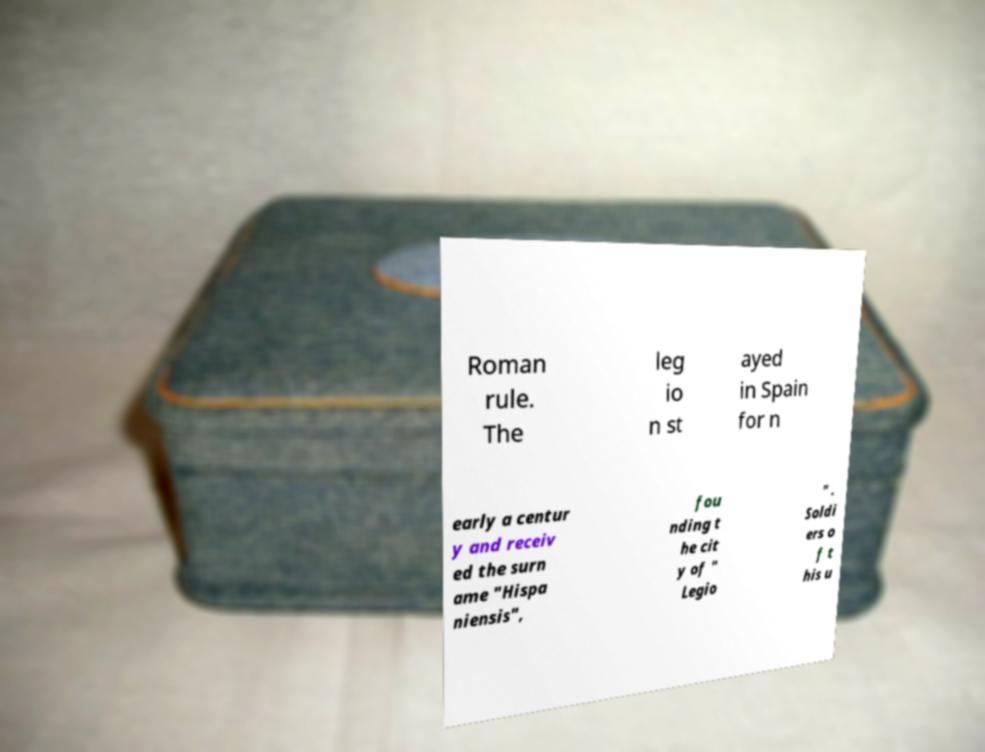What messages or text are displayed in this image? I need them in a readable, typed format. Roman rule. The leg io n st ayed in Spain for n early a centur y and receiv ed the surn ame "Hispa niensis", fou nding t he cit y of " Legio " . Soldi ers o f t his u 